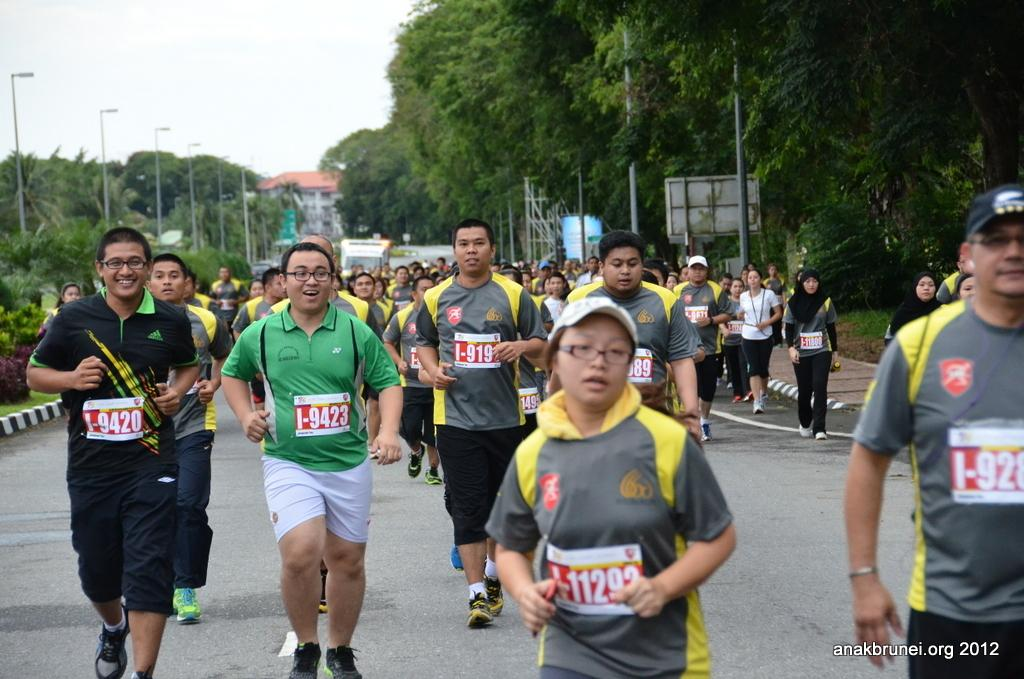How many people are in the image? There is a group of people in the image. What are the people doing in the image? The people are running on the road. What can be seen besides the people in the image? There are poles, trees, and at least one building visible in the image. What is visible in the background of the image? The sky is visible in the background of the image. How many pizzas can be seen floating in the ocean in the image? There is no ocean or pizzas present in the image. What type of tree is growing on the building in the image? There is no tree growing on a building in the image. 